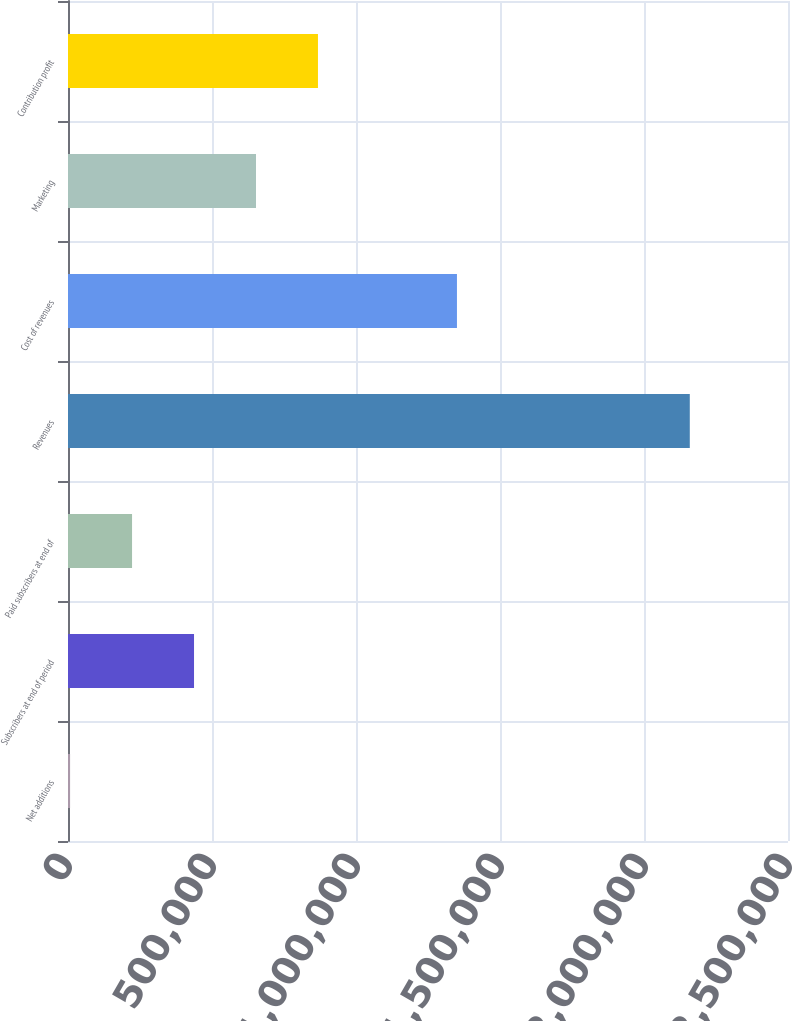Convert chart to OTSL. <chart><loc_0><loc_0><loc_500><loc_500><bar_chart><fcel>Net additions<fcel>Subscribers at end of period<fcel>Paid subscribers at end of<fcel>Revenues<fcel>Cost of revenues<fcel>Marketing<fcel>Contribution profit<nl><fcel>7233<fcel>437588<fcel>222410<fcel>2.15901e+06<fcel>1.35054e+06<fcel>652766<fcel>867943<nl></chart> 